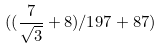Convert formula to latex. <formula><loc_0><loc_0><loc_500><loc_500>( ( \frac { 7 } { \sqrt { 3 } } + 8 ) / 1 9 7 + 8 7 )</formula> 